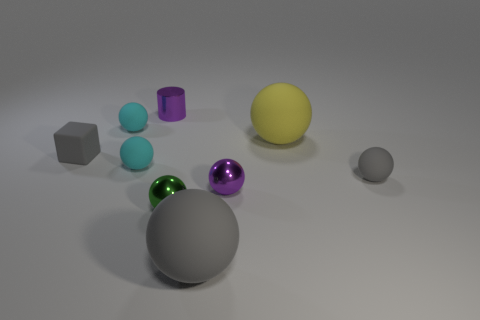Subtract all green balls. How many balls are left? 6 Subtract all yellow balls. How many balls are left? 6 Subtract 3 balls. How many balls are left? 4 Subtract all blue spheres. Subtract all cyan cylinders. How many spheres are left? 7 Add 1 blue shiny balls. How many objects exist? 10 Subtract all cylinders. How many objects are left? 8 Subtract 0 red balls. How many objects are left? 9 Subtract all large cyan balls. Subtract all yellow spheres. How many objects are left? 8 Add 1 cylinders. How many cylinders are left? 2 Add 2 tiny purple spheres. How many tiny purple spheres exist? 3 